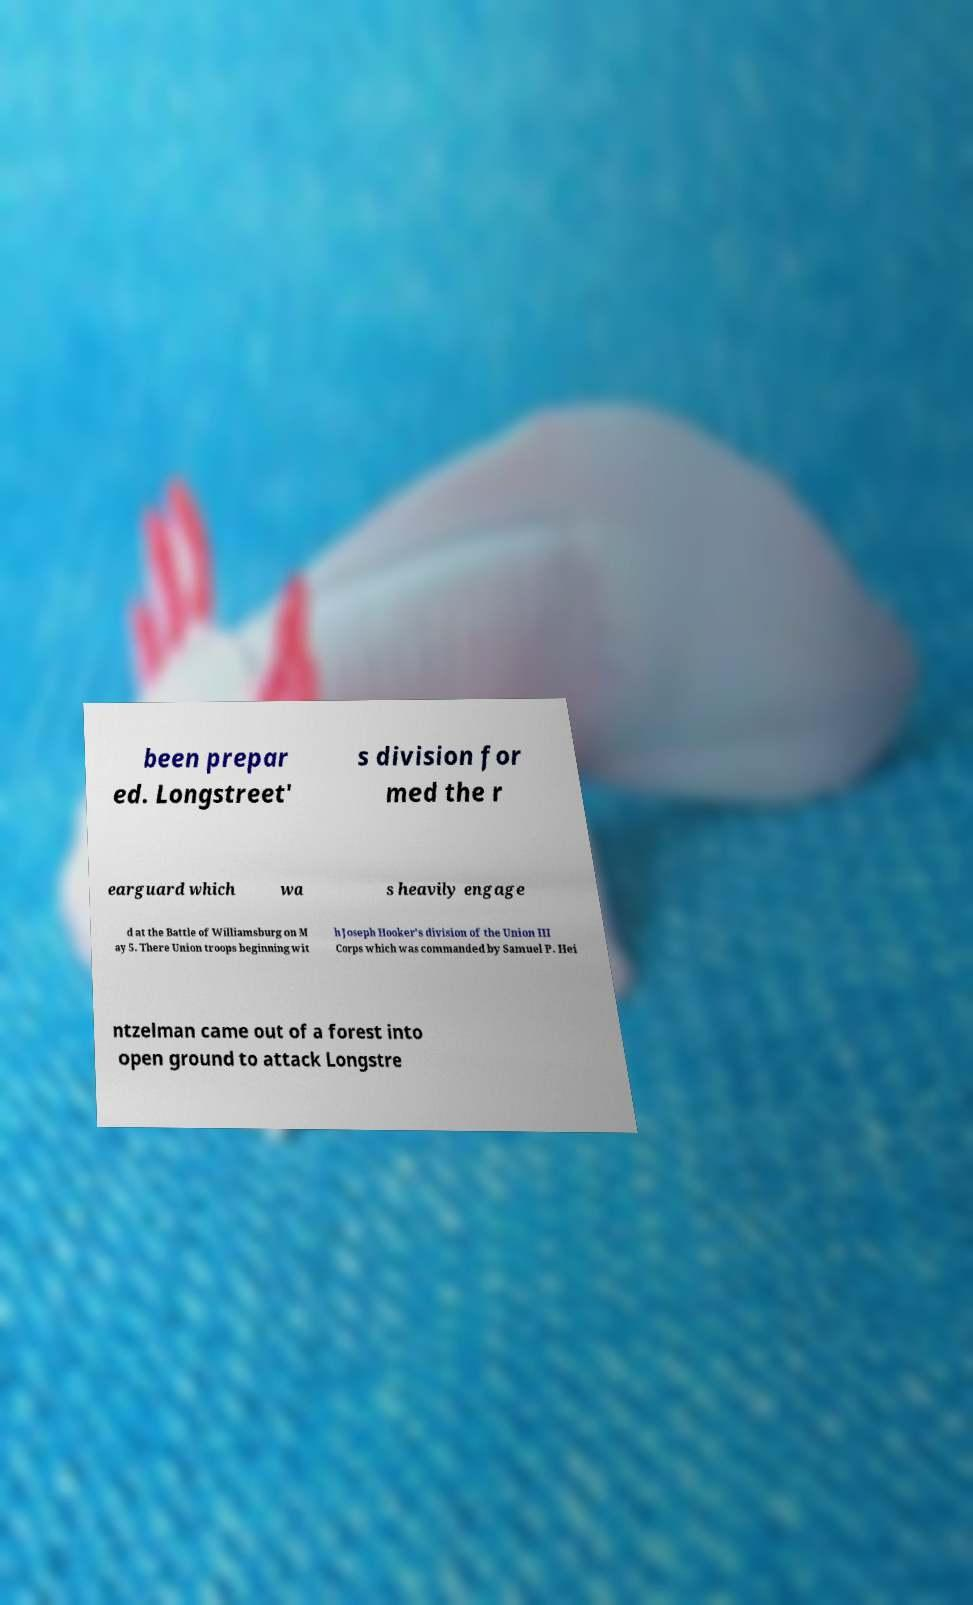Please identify and transcribe the text found in this image. been prepar ed. Longstreet' s division for med the r earguard which wa s heavily engage d at the Battle of Williamsburg on M ay 5. There Union troops beginning wit h Joseph Hooker's division of the Union III Corps which was commanded by Samuel P. Hei ntzelman came out of a forest into open ground to attack Longstre 